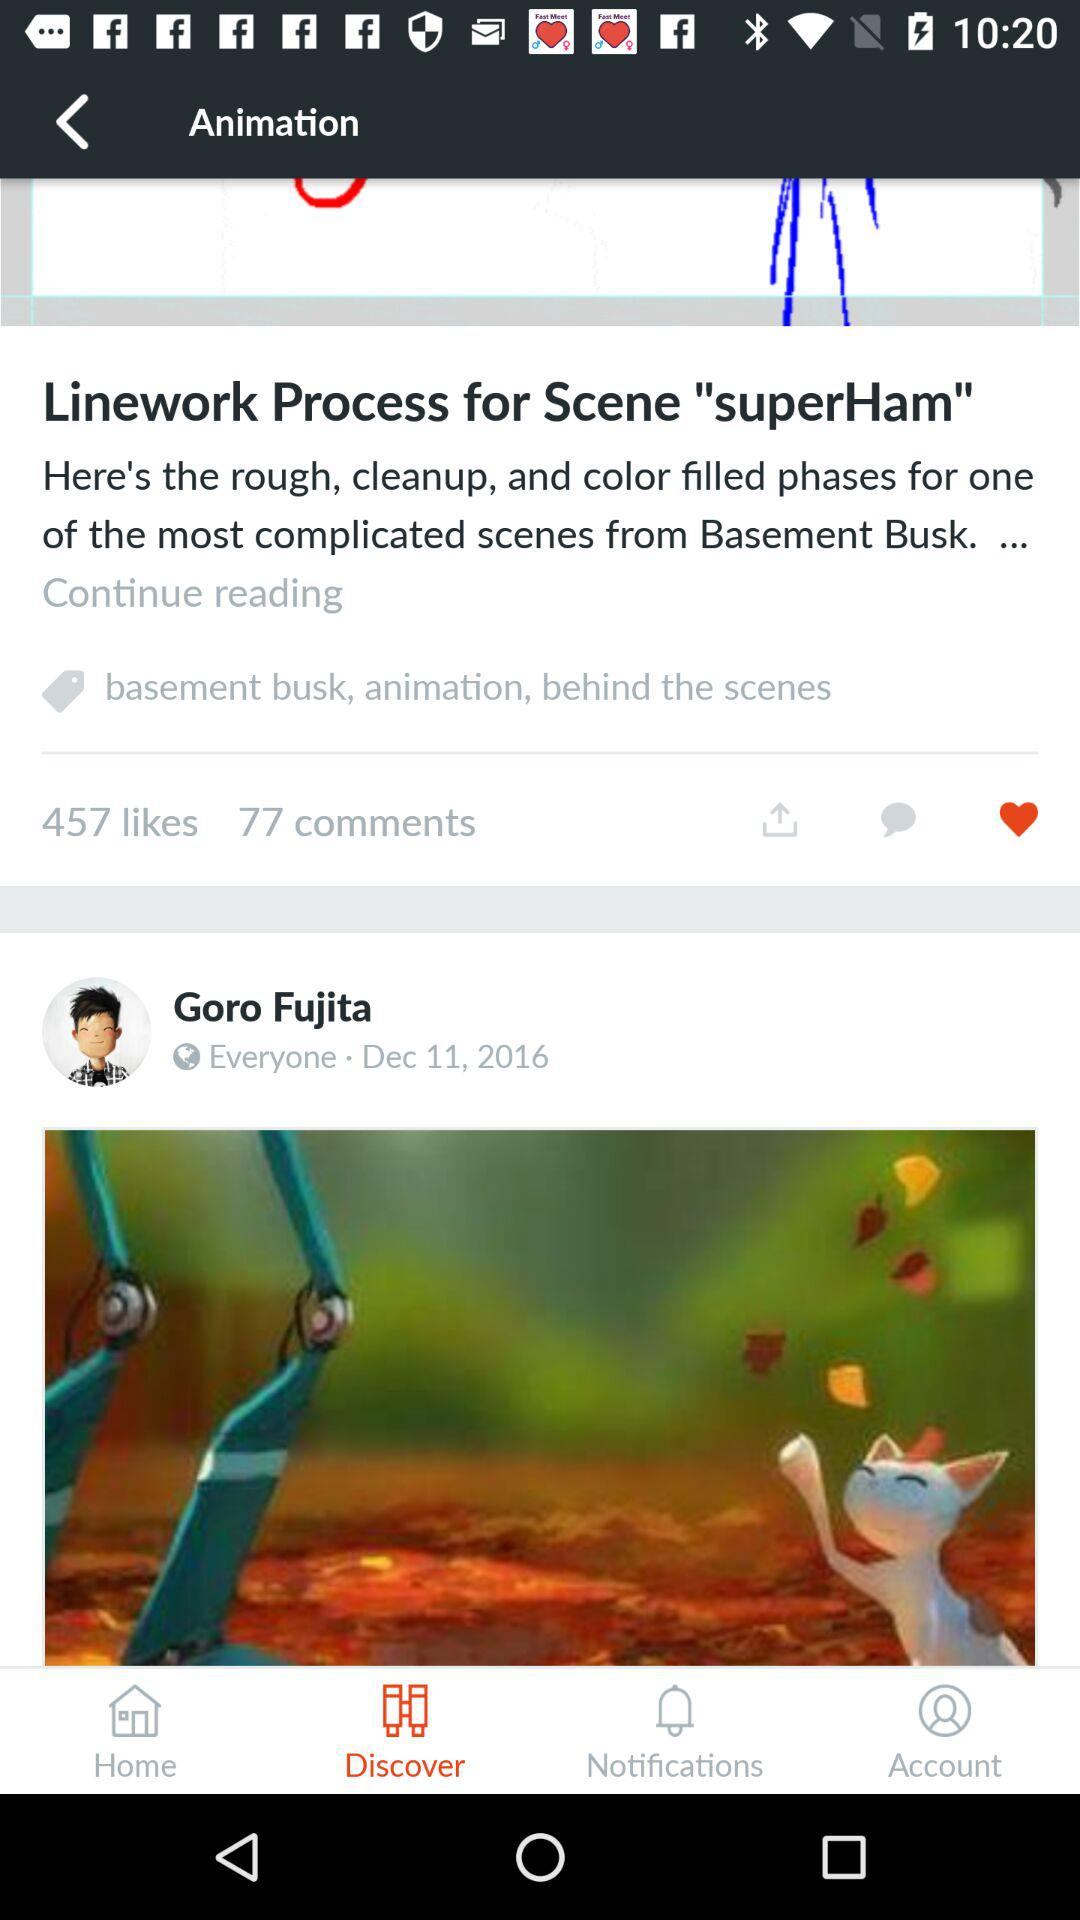How many more likes does this post have than comments?
Answer the question using a single word or phrase. 380 